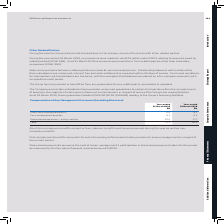According to Sophos Group's financial document, What do short-term employee benefits comprise? Based on the financial document, the answer is fees, salaries, benefits and bonuses earned during the year as well as nonmonetary benefits.. Also, What do post-employment benefits comprise? the cost of providing defined contribution pensions to senior management in respect of the current period.. The document states: "Post-employment benefits comprise the cost of providing defined contribution pensions to senior management in respect of the current period...." Also, What are the components making up the total Compensation of Key Management Personnel in the table? The document contains multiple relevant values: Short-term employee benefits, Post-employment benefits, Share-based payments - equity-settled. From the document: "Share-based payments - equity-settled 10.4 17.7 Post-employment benefits 0.1 0.1 Short-term employee benefits 6.6 9.1..." Additionally, In which year was the Total compensation of key management personnel larger? According to the financial document, 2018. The relevant text states: "RS 9 relating to amounts owed by related parties (2018: $Nil). As at 31 March 2019 no amounts were owed to or from related parties other than subsidiary c..." Also, can you calculate: What was the change in the Total compensation of key management personnel  in 2019 from 2018? Based on the calculation: 17.1-26.9, the result is -9.8 (in millions). This is based on the information: "Total 17.1 26.9 Total 17.1 26.9..." The key data points involved are: 17.1, 26.9. Also, can you calculate: What was the percentage change in the Total compensation of key management personnel  in 2019 from 2018? To answer this question, I need to perform calculations using the financial data. The calculation is: (17.1-26.9)/26.9, which equals -36.43 (percentage). This is based on the information: "Total 17.1 26.9 Total 17.1 26.9..." The key data points involved are: 17.1, 26.9. 